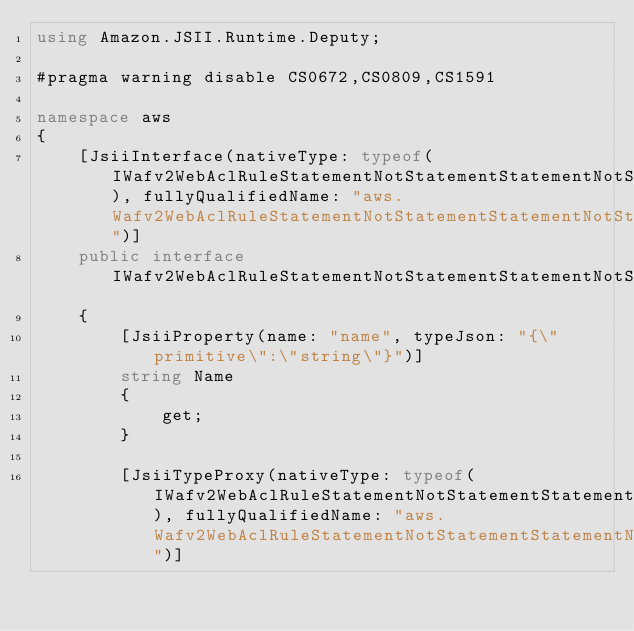<code> <loc_0><loc_0><loc_500><loc_500><_C#_>using Amazon.JSII.Runtime.Deputy;

#pragma warning disable CS0672,CS0809,CS1591

namespace aws
{
    [JsiiInterface(nativeType: typeof(IWafv2WebAclRuleStatementNotStatementStatementNotStatementStatementOrStatementStatementSizeConstraintStatementFieldToMatchSingleQueryArgument), fullyQualifiedName: "aws.Wafv2WebAclRuleStatementNotStatementStatementNotStatementStatementOrStatementStatementSizeConstraintStatementFieldToMatchSingleQueryArgument")]
    public interface IWafv2WebAclRuleStatementNotStatementStatementNotStatementStatementOrStatementStatementSizeConstraintStatementFieldToMatchSingleQueryArgument
    {
        [JsiiProperty(name: "name", typeJson: "{\"primitive\":\"string\"}")]
        string Name
        {
            get;
        }

        [JsiiTypeProxy(nativeType: typeof(IWafv2WebAclRuleStatementNotStatementStatementNotStatementStatementOrStatementStatementSizeConstraintStatementFieldToMatchSingleQueryArgument), fullyQualifiedName: "aws.Wafv2WebAclRuleStatementNotStatementStatementNotStatementStatementOrStatementStatementSizeConstraintStatementFieldToMatchSingleQueryArgument")]</code> 